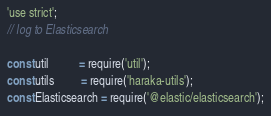<code> <loc_0><loc_0><loc_500><loc_500><_JavaScript_>'use strict';
// log to Elasticsearch

const util          = require('util');
const utils         = require('haraka-utils');
const Elasticsearch = require('@elastic/elasticsearch');
</code> 